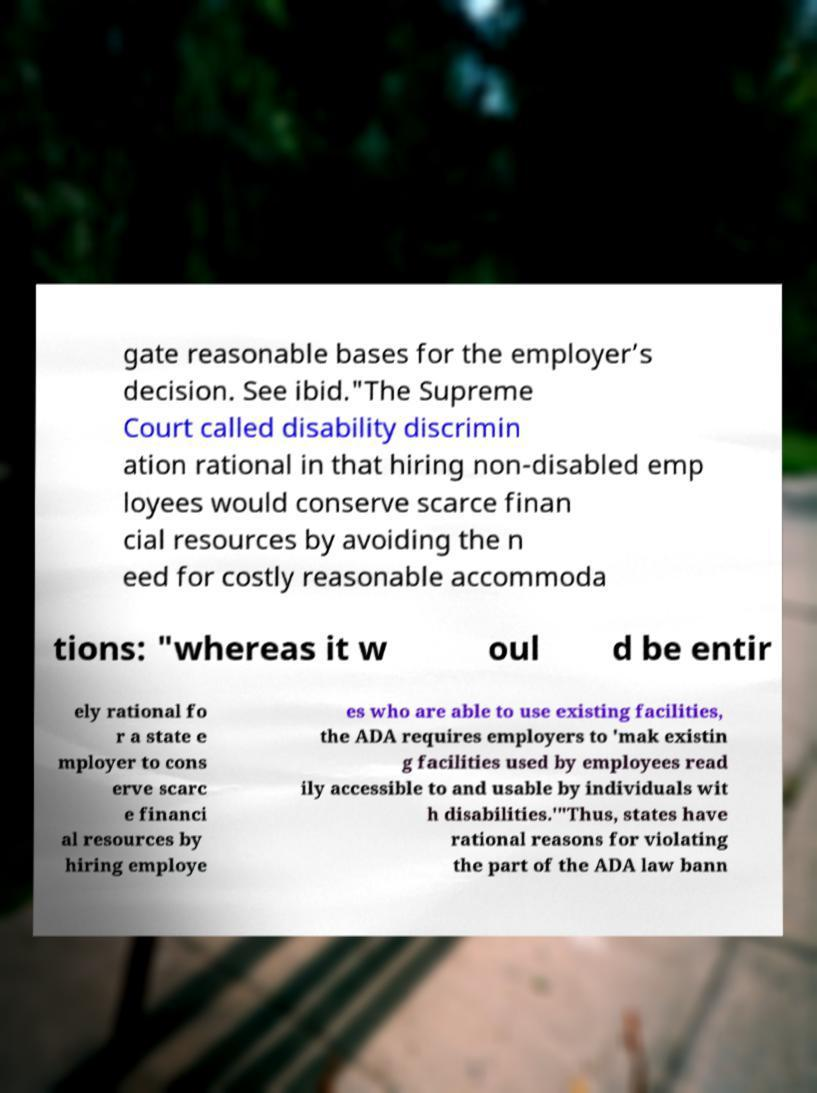What messages or text are displayed in this image? I need them in a readable, typed format. gate reasonable bases for the employer’s decision. See ibid."The Supreme Court called disability discrimin ation rational in that hiring non-disabled emp loyees would conserve scarce finan cial resources by avoiding the n eed for costly reasonable accommoda tions: "whereas it w oul d be entir ely rational fo r a state e mployer to cons erve scarc e financi al resources by hiring employe es who are able to use existing facilities, the ADA requires employers to 'mak existin g facilities used by employees read ily accessible to and usable by individuals wit h disabilities.'"Thus, states have rational reasons for violating the part of the ADA law bann 